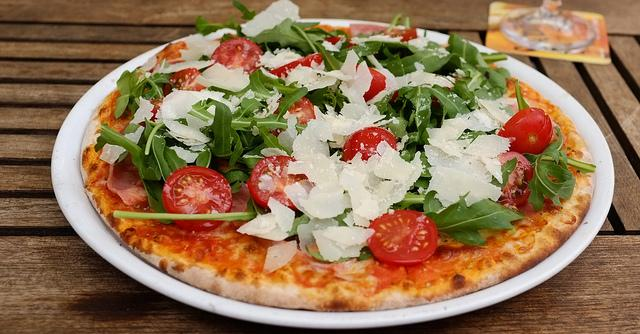Why would someone sit at this table?

Choices:
A) to work
B) to eat
C) to paint
D) to sew to eat 